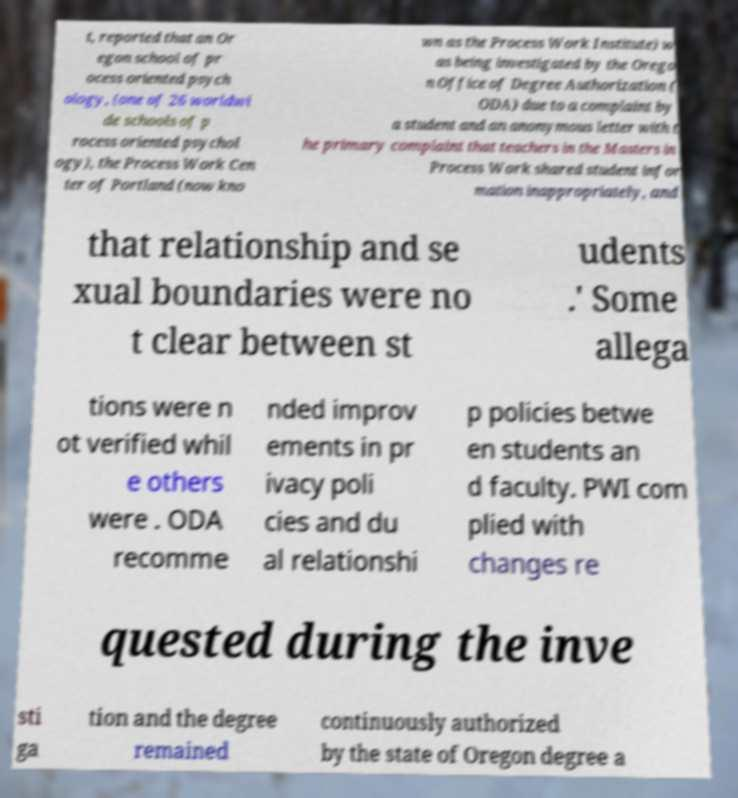Please read and relay the text visible in this image. What does it say? t, reported that an Or egon school of pr ocess oriented psych ology, (one of 26 worldwi de schools of p rocess oriented psychol ogy), the Process Work Cen ter of Portland (now kno wn as the Process Work Institute) w as being investigated by the Orego n Office of Degree Authorization ( ODA) due to a complaint by a student and an anonymous letter with t he primary complaint that teachers in the Masters in Process Work shared student infor mation inappropriately, and that relationship and se xual boundaries were no t clear between st udents .' Some allega tions were n ot verified whil e others were . ODA recomme nded improv ements in pr ivacy poli cies and du al relationshi p policies betwe en students an d faculty. PWI com plied with changes re quested during the inve sti ga tion and the degree remained continuously authorized by the state of Oregon degree a 